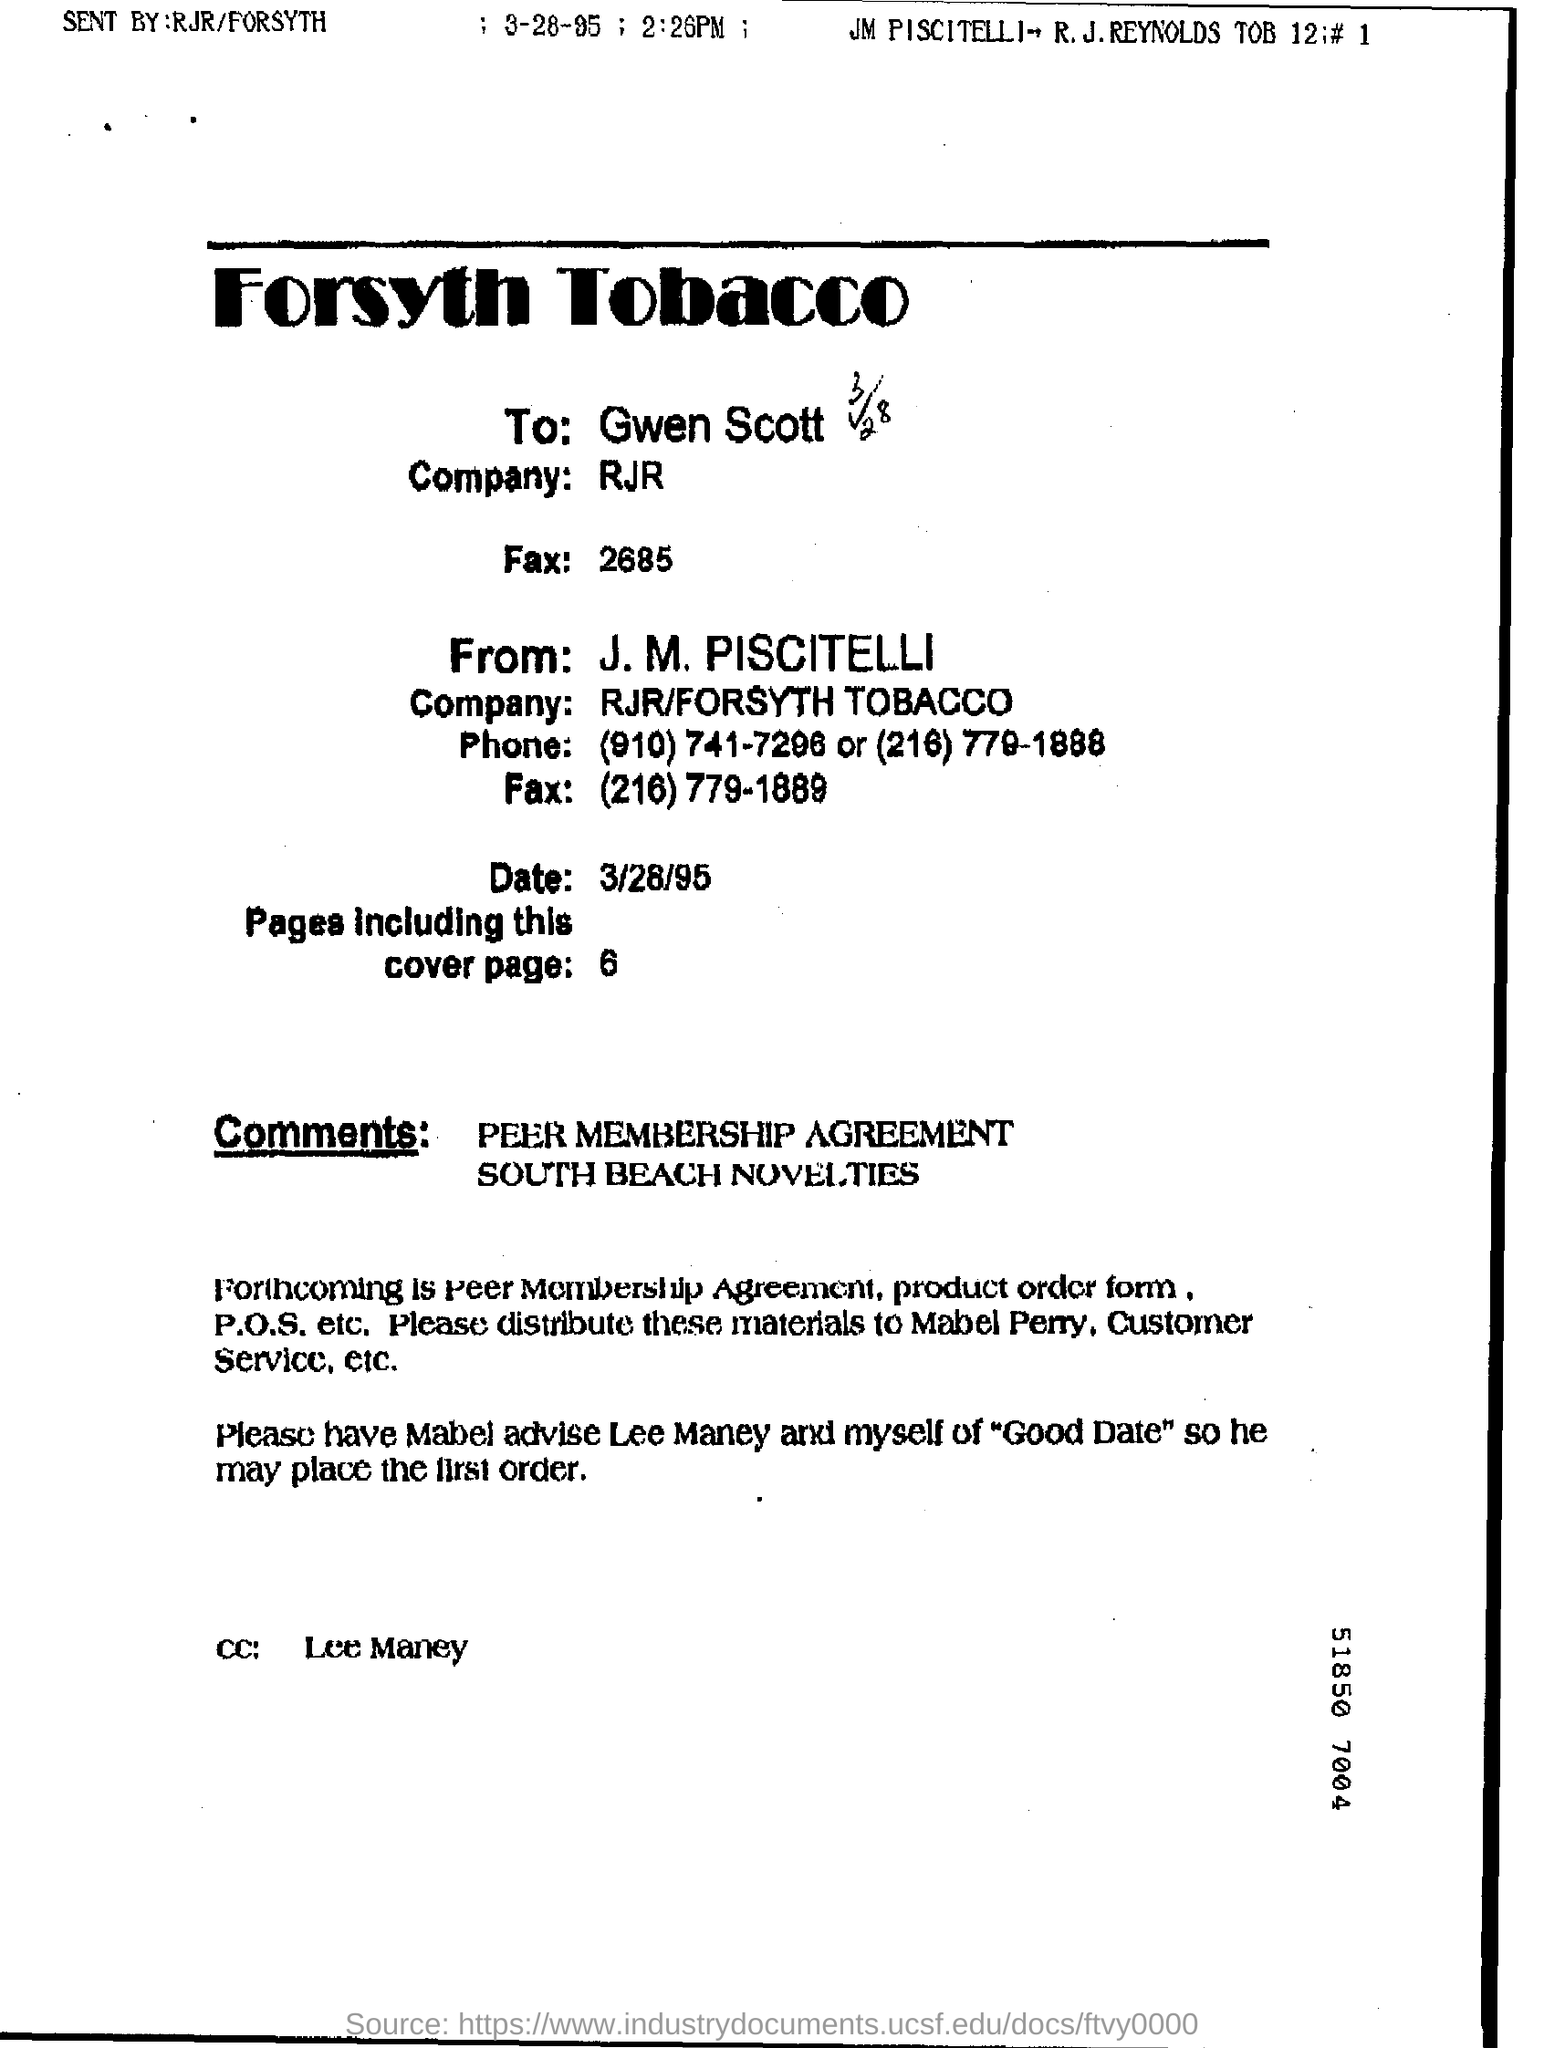Specify some key components in this picture. The letter is addressed to Gwen Scott. 